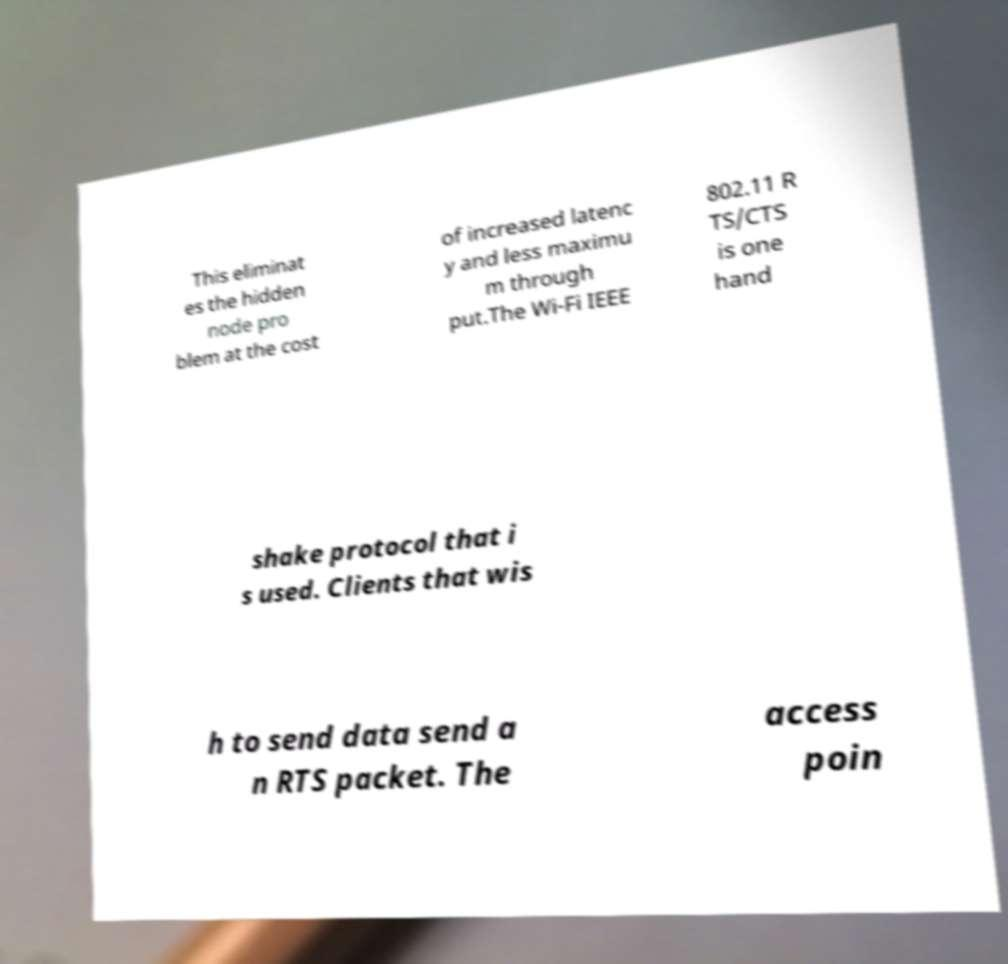Can you accurately transcribe the text from the provided image for me? This eliminat es the hidden node pro blem at the cost of increased latenc y and less maximu m through put.The Wi-Fi IEEE 802.11 R TS/CTS is one hand shake protocol that i s used. Clients that wis h to send data send a n RTS packet. The access poin 